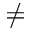Convert formula to latex. <formula><loc_0><loc_0><loc_500><loc_500>\neq</formula> 